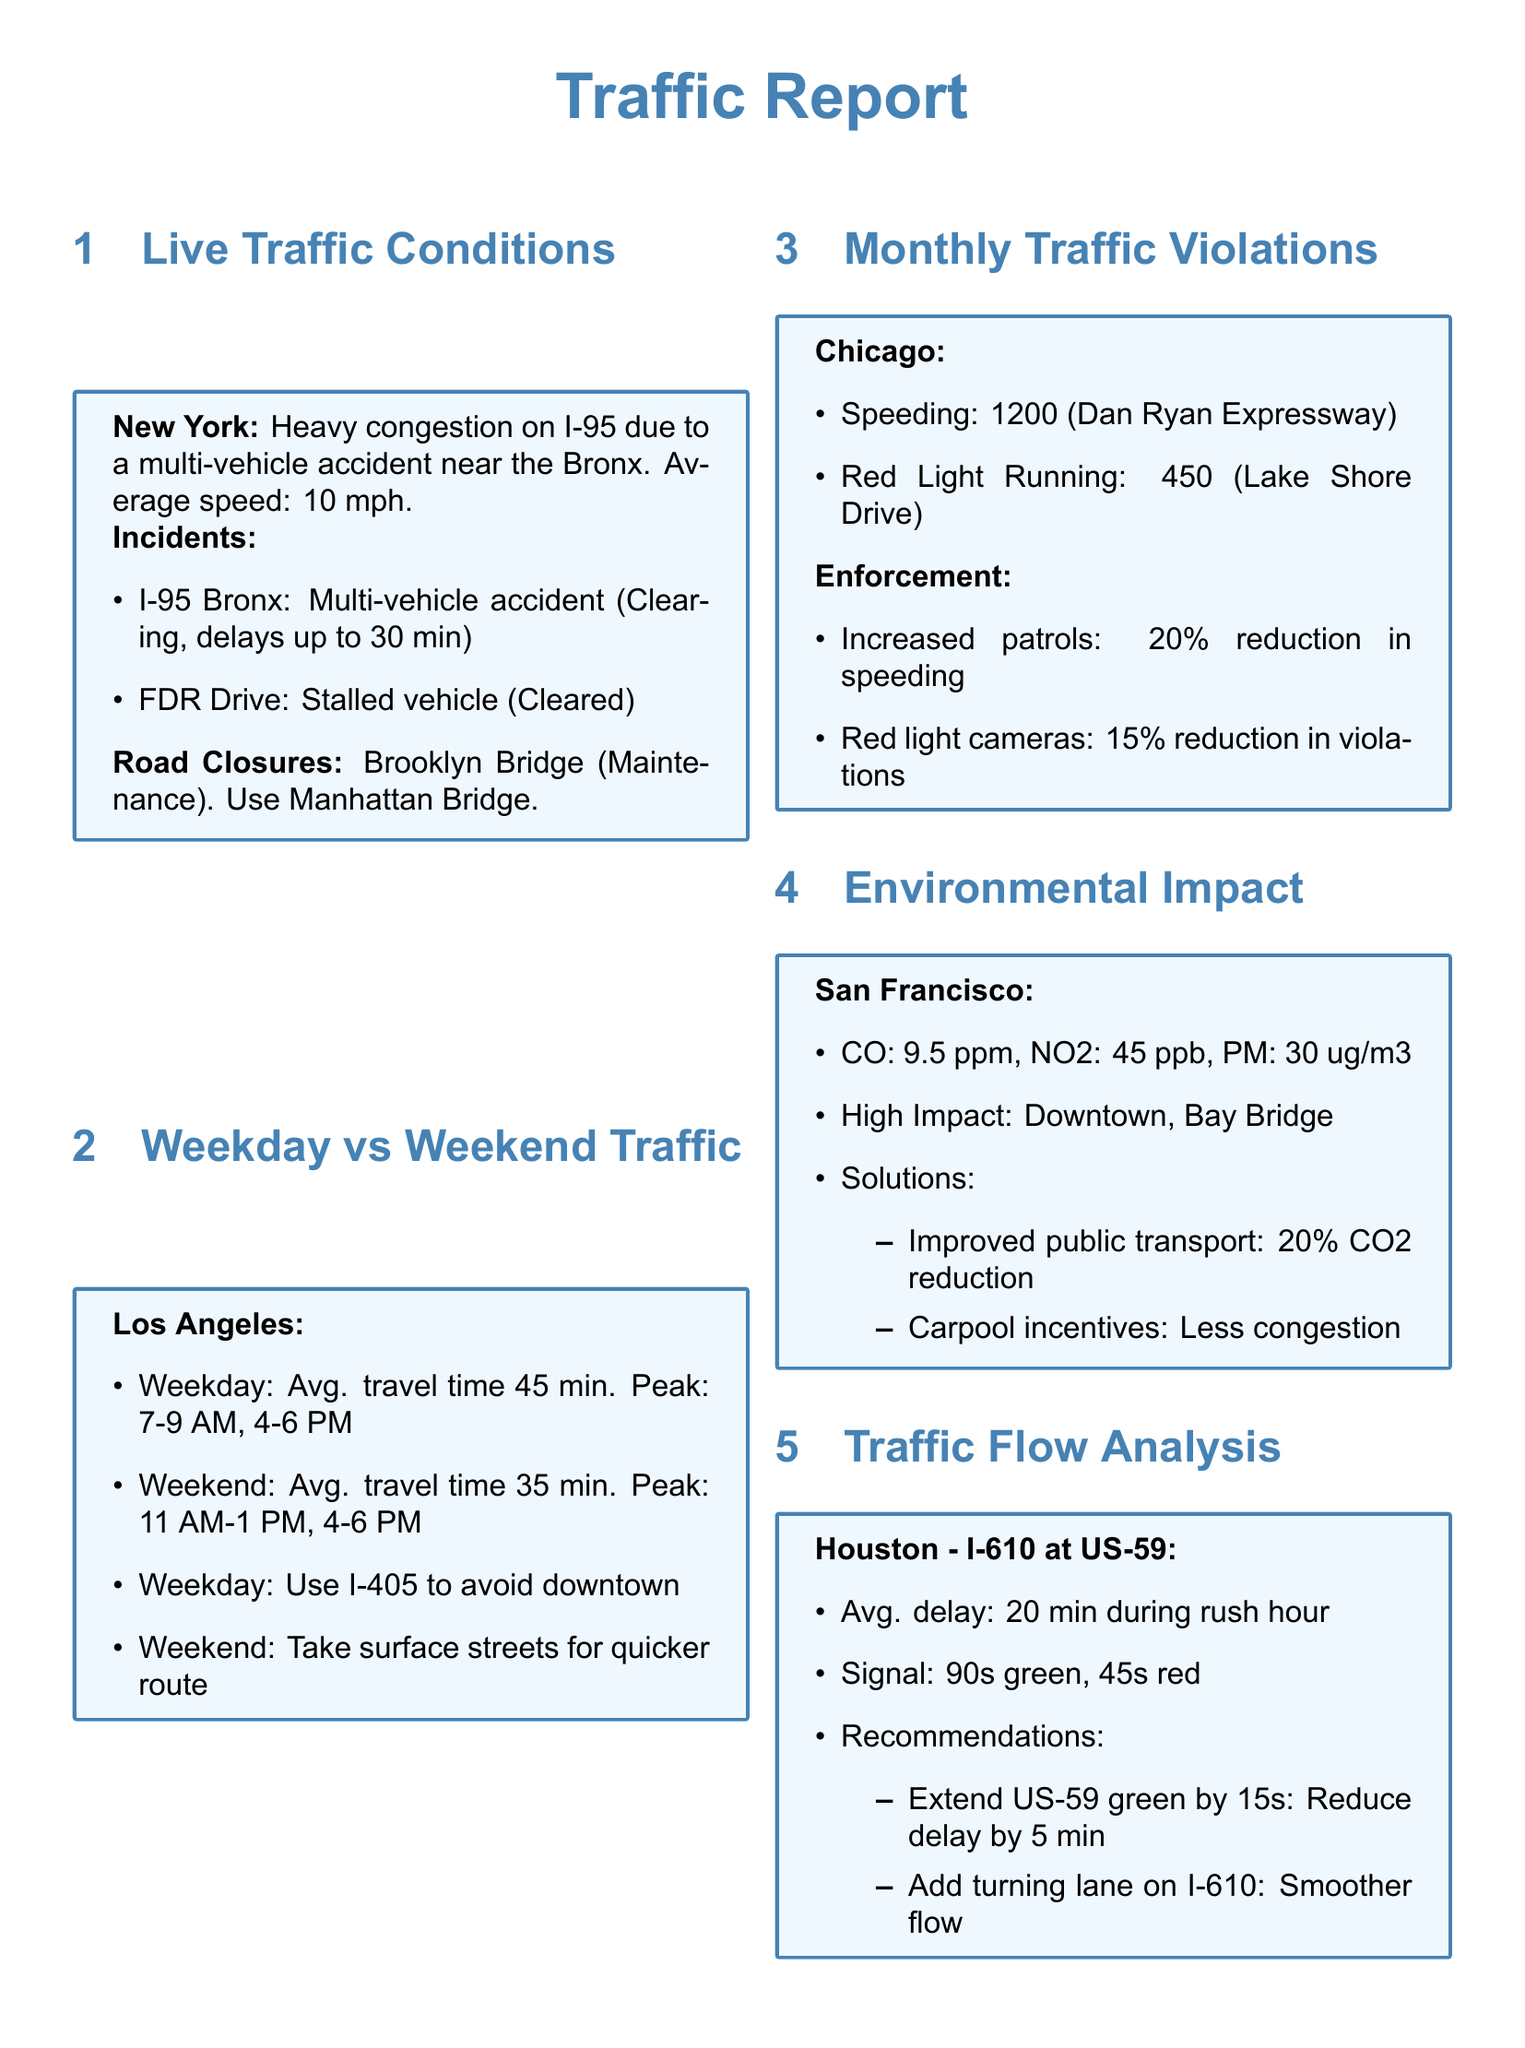What is the average speed on I-95? The average speed on I-95 due to heavy congestion is mentioned as 10 mph.
Answer: 10 mph What is the average travel time on weekends in Los Angeles? The document states that the average travel time on weekends in Los Angeles is 35 minutes.
Answer: 35 min How many speeding violations were reported in Chicago? The document indicates that there were 1200 speeding violations recorded on the Dan Ryan Expressway.
Answer: 1200 What are the primary pollutants measured in San Francisco? The report lists CO, NO2, and PM as the primary pollutants measured in San Francisco.
Answer: CO, NO2, PM How much did speeding enforcement reduce violations by? The report states that enforcement led to a 20% reduction in speeding violations.
Answer: 20% What is the average delay at I-610 during rush hour? The document notes that the average delay at I-610 during rush hour is 20 minutes.
Answer: 20 min What maintenance is currently affecting the Brooklyn Bridge? The document mentions that the Brooklyn Bridge is closed due to maintenance.
Answer: Maintenance What is the suggested alternative route for weekday commuters in Los Angeles? The report advises commuters to use I-405 to avoid downtown during weekdays.
Answer: I-405 Which two areas in San Francisco are highlighted for high environmental impact? The report highlights Downtown and Bay Bridge as areas with high environmental impact.
Answer: Downtown, Bay Bridge 